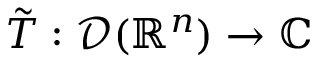Convert formula to latex. <formula><loc_0><loc_0><loc_500><loc_500>{ \tilde { T } } \colon { \mathcal { D } } ( \mathbb { R } ^ { n } ) \to \mathbb { C }</formula> 